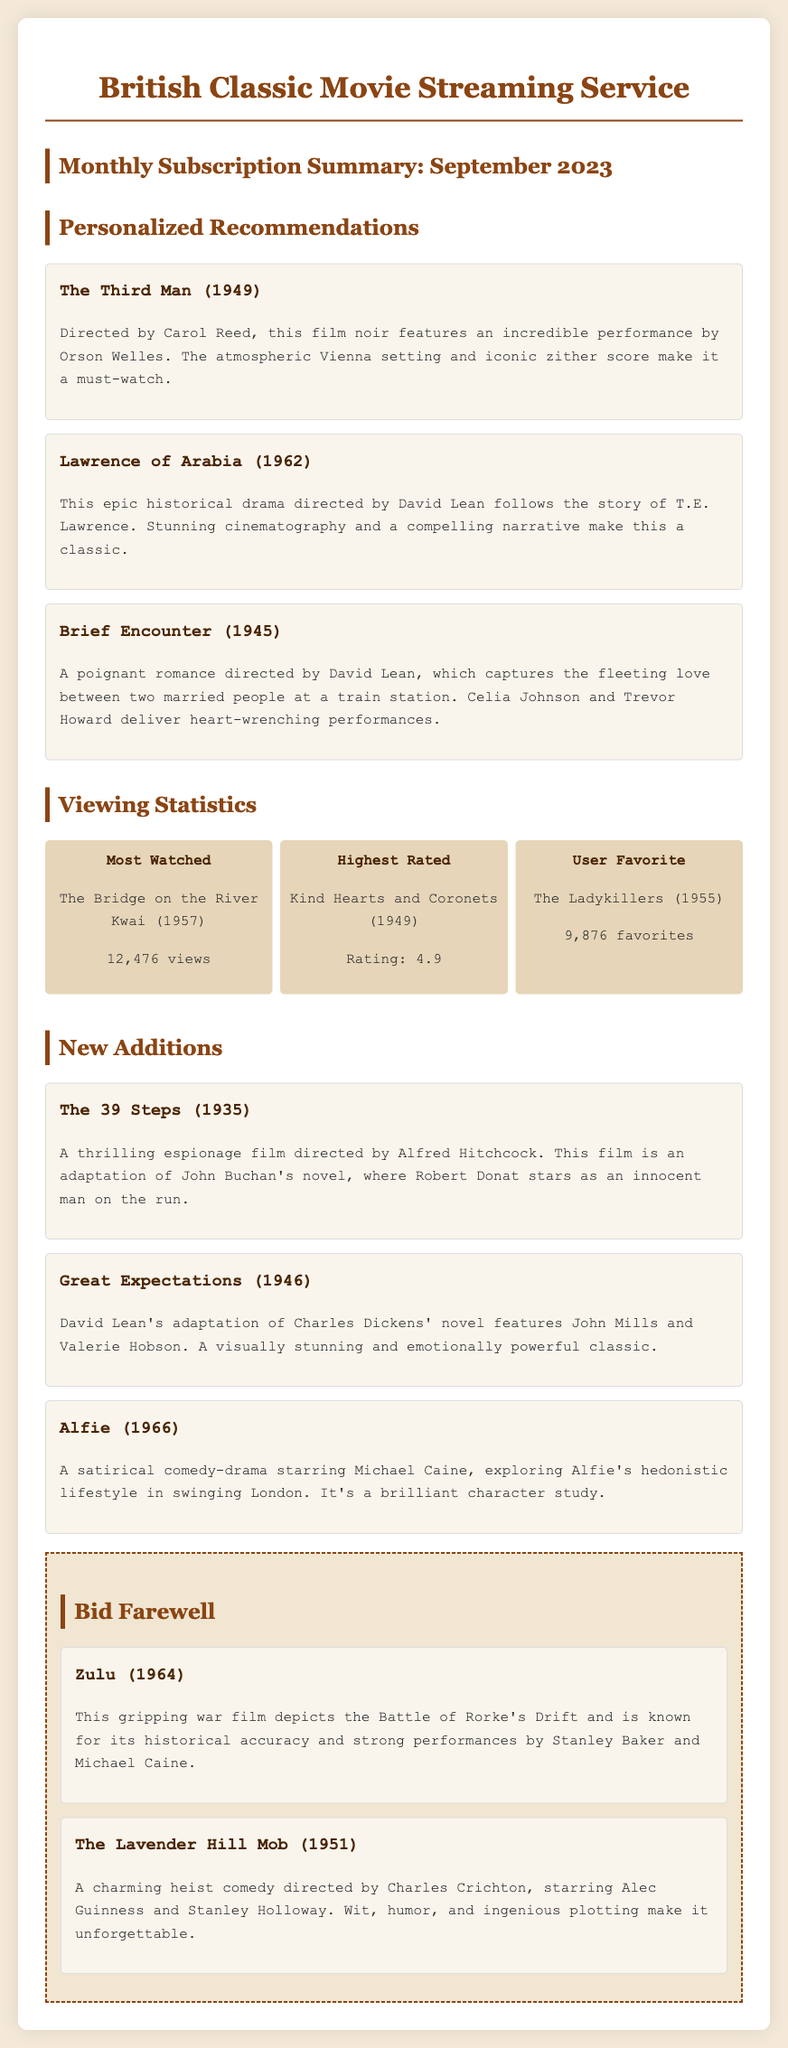What is the title of the most watched movie? The title of the most watched movie is mentioned in the viewing statistics section as The Bridge on the River Kwai.
Answer: The Bridge on the River Kwai Who directed Brief Encounter? The director of Brief Encounter is stated in the personalized recommendations section as David Lean.
Answer: David Lean What is the highest rating for a movie? The highest rating for a movie is provided in the viewing statistics section as 4.9 for Kind Hearts and Coronets.
Answer: 4.9 Which movie is considered the user favorite? The user favorite movie listed in the viewing statistics is The Ladykillers, as mentioned in the document.
Answer: The Ladykillers What year was The 39 Steps released? The year of release for The 39 Steps, found in the new additions section, is 1935.
Answer: 1935 Which film is categorized as a satirical comedy-drama? The film identified as a satirical comedy-drama in the new additions section is Alfie.
Answer: Alfie How many views did The Bridge on the River Kwai receive? The number of views for The Bridge on the River Kwai is stated in the viewing statistics as 12,476 views.
Answer: 12,476 views What is the title of a film that depicts the Battle of Rorke's Drift? The title of the film depicting the Battle of Rorke's Drift, mentioned in the bid farewell section, is Zulu.
Answer: Zulu Who stars in Great Expectations? The stars of Great Expectations, as noted in the new additions section, are John Mills and Valerie Hobson.
Answer: John Mills and Valerie Hobson 